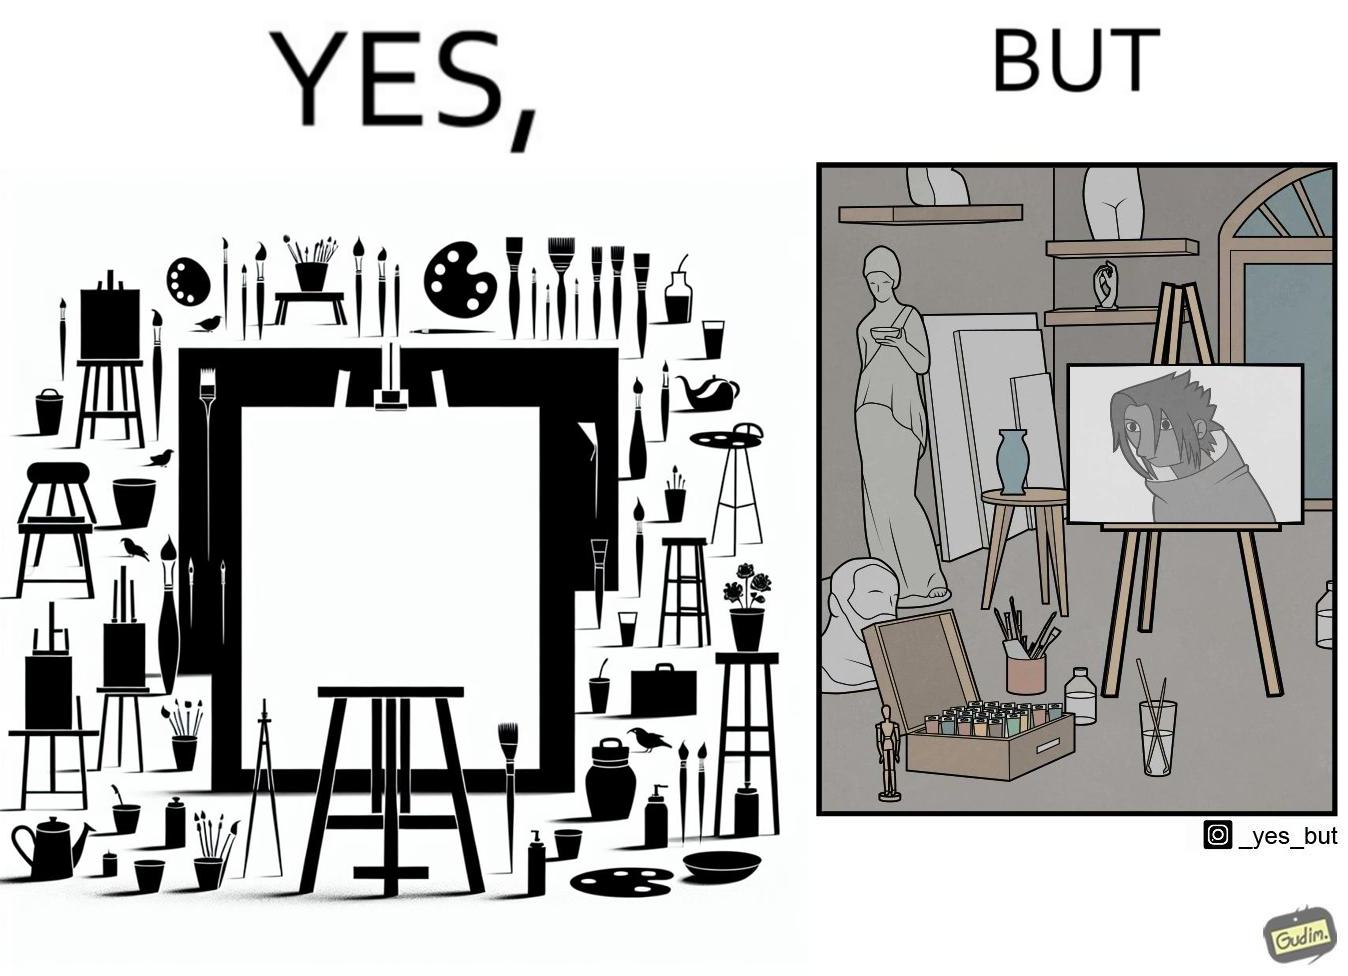Does this image contain satire or humor? Yes, this image is satirical. 